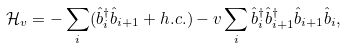<formula> <loc_0><loc_0><loc_500><loc_500>\mathcal { H } _ { v } = - \sum _ { i } ( \hat { b } _ { i } ^ { \dagger } \hat { b } _ { i + 1 } + h . c . ) - v \sum _ { i } \hat { b } _ { i } ^ { \dagger } \hat { b } _ { i + 1 } ^ { \dagger } \hat { b } _ { i + 1 } \hat { b } _ { i } ,</formula> 